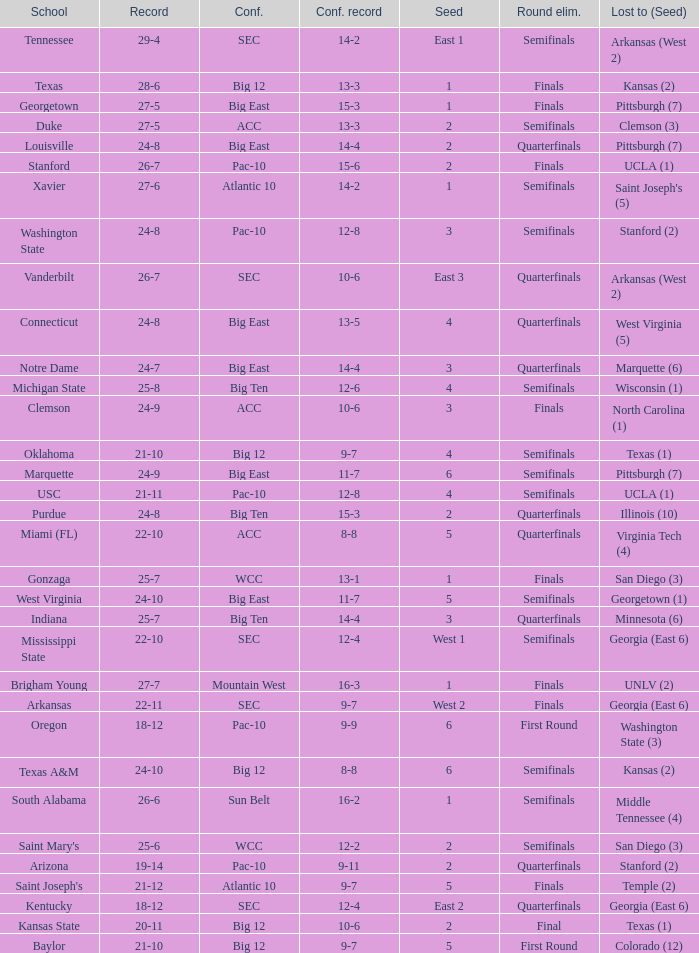Name the conference record where seed is 3 and record is 24-9 10-6. 